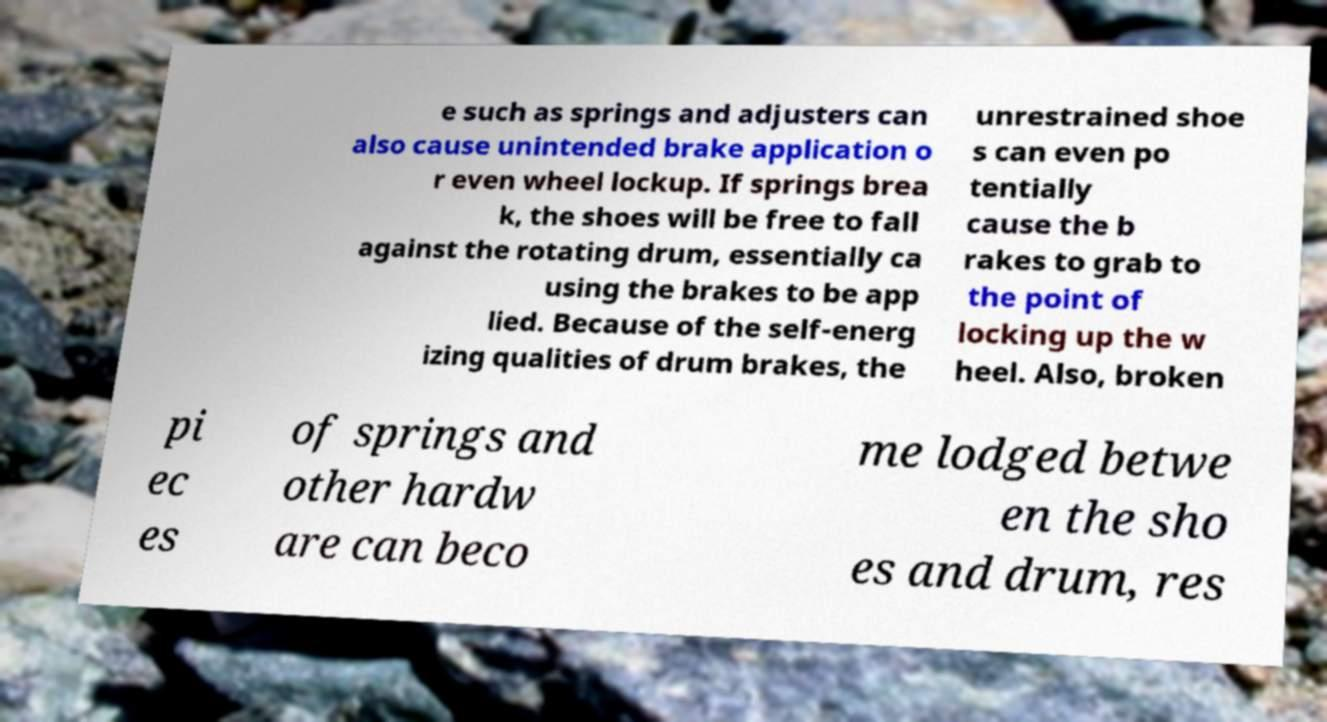For documentation purposes, I need the text within this image transcribed. Could you provide that? e such as springs and adjusters can also cause unintended brake application o r even wheel lockup. If springs brea k, the shoes will be free to fall against the rotating drum, essentially ca using the brakes to be app lied. Because of the self-energ izing qualities of drum brakes, the unrestrained shoe s can even po tentially cause the b rakes to grab to the point of locking up the w heel. Also, broken pi ec es of springs and other hardw are can beco me lodged betwe en the sho es and drum, res 